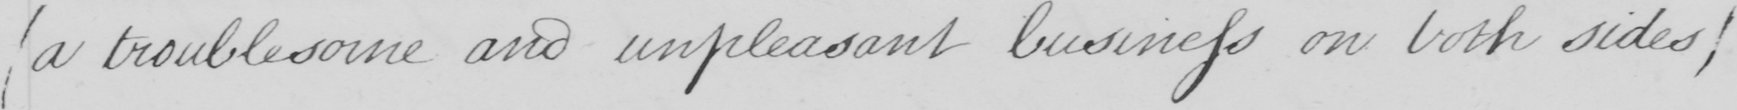What text is written in this handwritten line? ( a troublesome and unpleasant business on both sides ) 